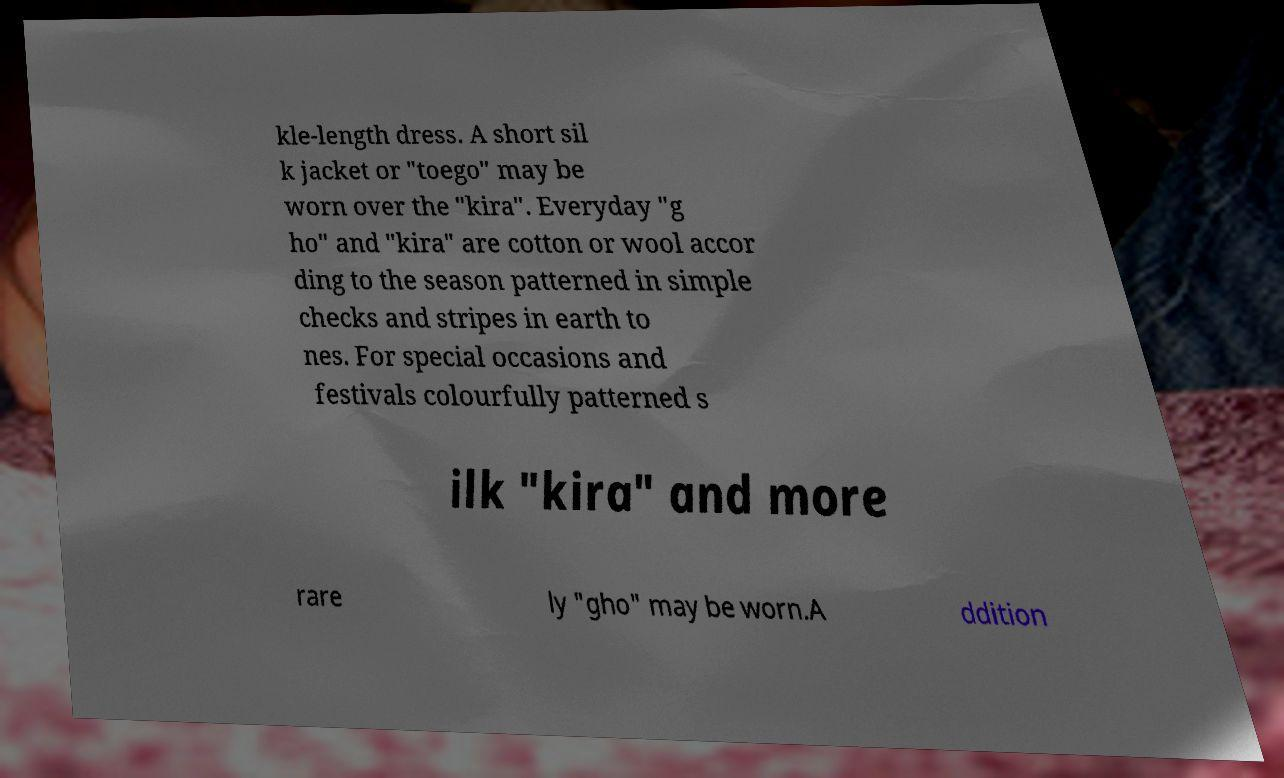What messages or text are displayed in this image? I need them in a readable, typed format. kle-length dress. A short sil k jacket or "toego" may be worn over the "kira". Everyday "g ho" and "kira" are cotton or wool accor ding to the season patterned in simple checks and stripes in earth to nes. For special occasions and festivals colourfully patterned s ilk "kira" and more rare ly "gho" may be worn.A ddition 